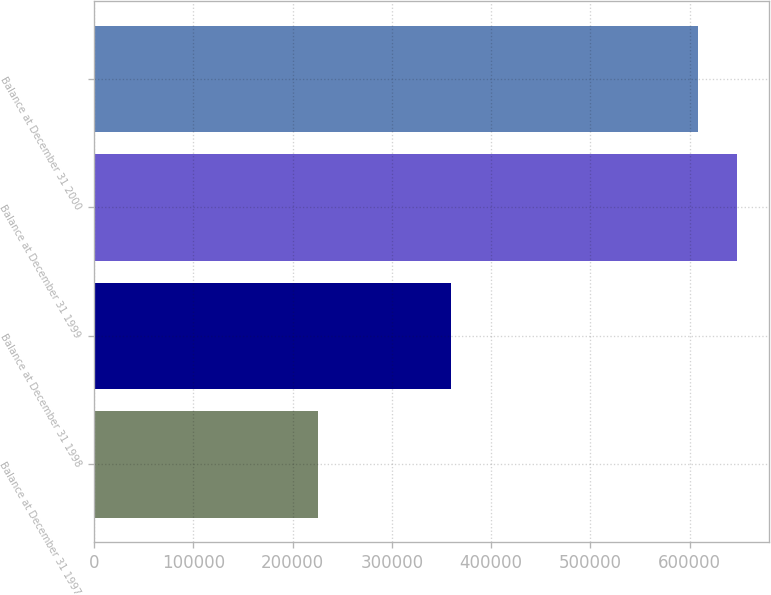<chart> <loc_0><loc_0><loc_500><loc_500><bar_chart><fcel>Balance at December 31 1997<fcel>Balance at December 31 1998<fcel>Balance at December 31 1999<fcel>Balance at December 31 2000<nl><fcel>225000<fcel>360000<fcel>647374<fcel>608874<nl></chart> 